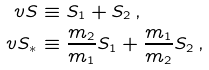Convert formula to latex. <formula><loc_0><loc_0><loc_500><loc_500>\ v S & \equiv S _ { 1 } + { S } _ { 2 } \, , \\ \ v S _ { * } & \equiv \frac { m _ { 2 } } { m _ { 1 } } { S } _ { 1 } + \frac { m _ { 1 } } { m _ { 2 } } { S } _ { 2 } \, ,</formula> 